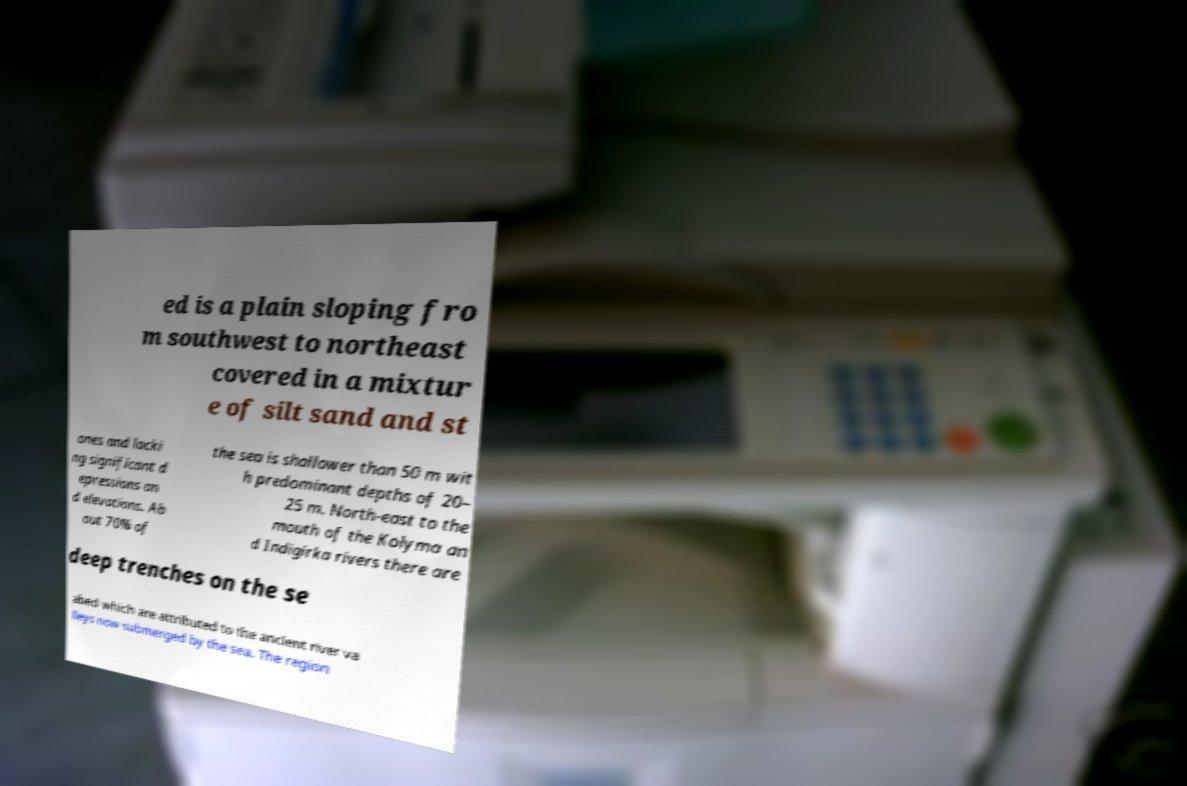Can you read and provide the text displayed in the image?This photo seems to have some interesting text. Can you extract and type it out for me? ed is a plain sloping fro m southwest to northeast covered in a mixtur e of silt sand and st ones and lacki ng significant d epressions an d elevations. Ab out 70% of the sea is shallower than 50 m wit h predominant depths of 20– 25 m. North-east to the mouth of the Kolyma an d Indigirka rivers there are deep trenches on the se abed which are attributed to the ancient river va lleys now submerged by the sea. The region 